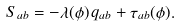Convert formula to latex. <formula><loc_0><loc_0><loc_500><loc_500>S _ { a b } = - \lambda ( \phi ) \, q _ { a b } + \tau _ { a b } ( \phi ) .</formula> 